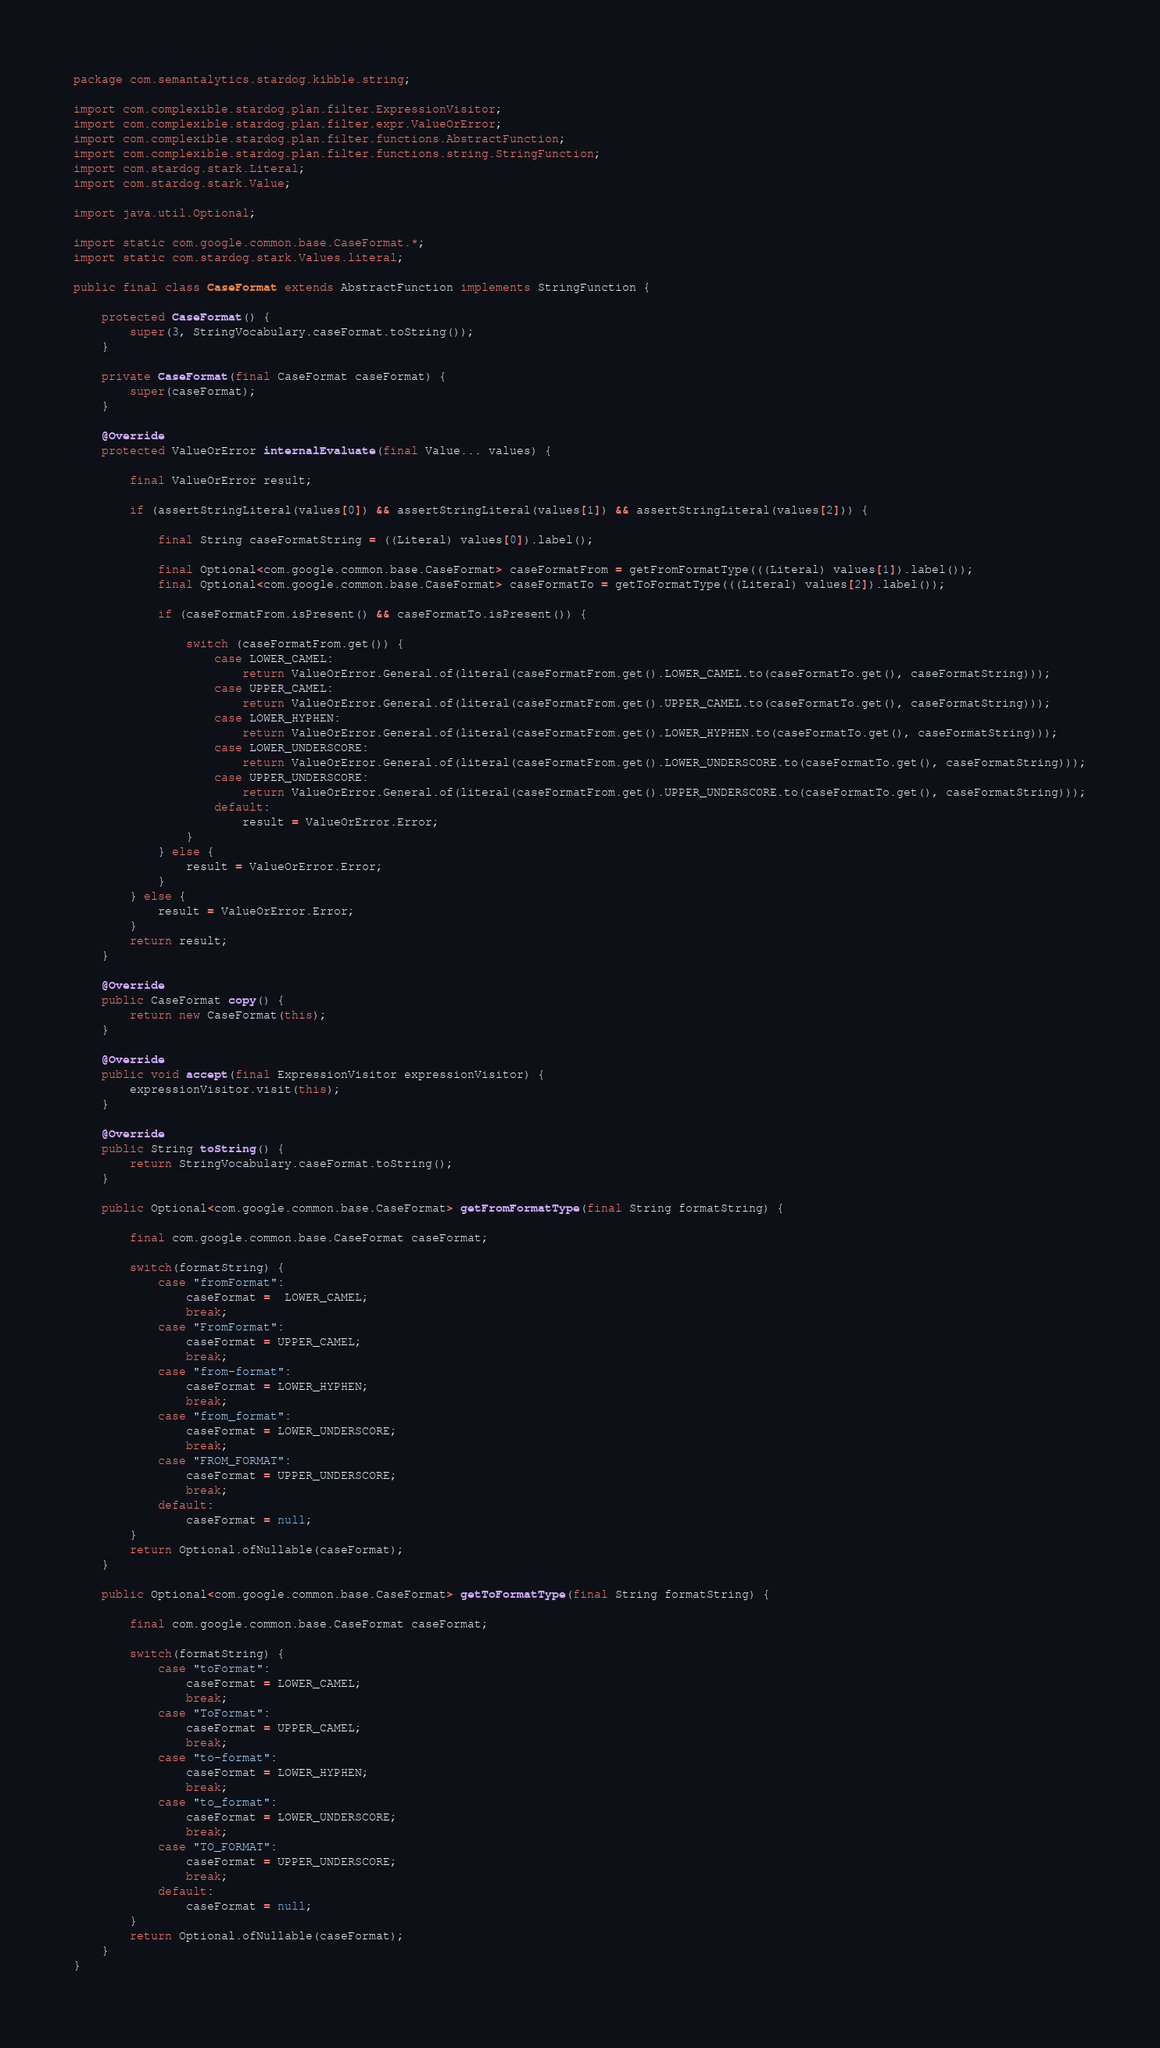<code> <loc_0><loc_0><loc_500><loc_500><_Java_>package com.semantalytics.stardog.kibble.string;

import com.complexible.stardog.plan.filter.ExpressionVisitor;
import com.complexible.stardog.plan.filter.expr.ValueOrError;
import com.complexible.stardog.plan.filter.functions.AbstractFunction;
import com.complexible.stardog.plan.filter.functions.string.StringFunction;
import com.stardog.stark.Literal;
import com.stardog.stark.Value;

import java.util.Optional;

import static com.google.common.base.CaseFormat.*;
import static com.stardog.stark.Values.literal;

public final class CaseFormat extends AbstractFunction implements StringFunction {

    protected CaseFormat() {
        super(3, StringVocabulary.caseFormat.toString());
    }

    private CaseFormat(final CaseFormat caseFormat) {
        super(caseFormat);
    }

    @Override
    protected ValueOrError internalEvaluate(final Value... values) {

        final ValueOrError result;

        if (assertStringLiteral(values[0]) && assertStringLiteral(values[1]) && assertStringLiteral(values[2])) {

            final String caseFormatString = ((Literal) values[0]).label();

            final Optional<com.google.common.base.CaseFormat> caseFormatFrom = getFromFormatType(((Literal) values[1]).label());
            final Optional<com.google.common.base.CaseFormat> caseFormatTo = getToFormatType(((Literal) values[2]).label());

            if (caseFormatFrom.isPresent() && caseFormatTo.isPresent()) {

                switch (caseFormatFrom.get()) {
                    case LOWER_CAMEL:
                        return ValueOrError.General.of(literal(caseFormatFrom.get().LOWER_CAMEL.to(caseFormatTo.get(), caseFormatString)));
                    case UPPER_CAMEL:
                        return ValueOrError.General.of(literal(caseFormatFrom.get().UPPER_CAMEL.to(caseFormatTo.get(), caseFormatString)));
                    case LOWER_HYPHEN:
                        return ValueOrError.General.of(literal(caseFormatFrom.get().LOWER_HYPHEN.to(caseFormatTo.get(), caseFormatString)));
                    case LOWER_UNDERSCORE:
                        return ValueOrError.General.of(literal(caseFormatFrom.get().LOWER_UNDERSCORE.to(caseFormatTo.get(), caseFormatString)));
                    case UPPER_UNDERSCORE:
                        return ValueOrError.General.of(literal(caseFormatFrom.get().UPPER_UNDERSCORE.to(caseFormatTo.get(), caseFormatString)));
                    default:
                        result = ValueOrError.Error;
                }
            } else {
                result = ValueOrError.Error;
            }
        } else {
            result = ValueOrError.Error;
        }
        return result;
    }

    @Override
    public CaseFormat copy() {
        return new CaseFormat(this);
    }

    @Override
    public void accept(final ExpressionVisitor expressionVisitor) {
        expressionVisitor.visit(this);
    }

    @Override
    public String toString() {
        return StringVocabulary.caseFormat.toString();
    }

    public Optional<com.google.common.base.CaseFormat> getFromFormatType(final String formatString) {

        final com.google.common.base.CaseFormat caseFormat;

        switch(formatString) {
            case "fromFormat":
                caseFormat =  LOWER_CAMEL;
                break;
            case "FromFormat":
                caseFormat = UPPER_CAMEL;
                break;
            case "from-format":
                caseFormat = LOWER_HYPHEN;
                break;
            case "from_format":
                caseFormat = LOWER_UNDERSCORE;
                break;
            case "FROM_FORMAT":
                caseFormat = UPPER_UNDERSCORE;
                break;
            default:
                caseFormat = null;
        }
        return Optional.ofNullable(caseFormat);
    }

    public Optional<com.google.common.base.CaseFormat> getToFormatType(final String formatString) {

        final com.google.common.base.CaseFormat caseFormat;

        switch(formatString) {
            case "toFormat":
                caseFormat = LOWER_CAMEL;
                break;
            case "ToFormat":
                caseFormat = UPPER_CAMEL;
                break;
            case "to-format":
                caseFormat = LOWER_HYPHEN;
                break;
            case "to_format":
                caseFormat = LOWER_UNDERSCORE;
                break;
            case "TO_FORMAT":
                caseFormat = UPPER_UNDERSCORE;
                break;
            default:
                caseFormat = null;
        }
        return Optional.ofNullable(caseFormat);
    }
}
</code> 